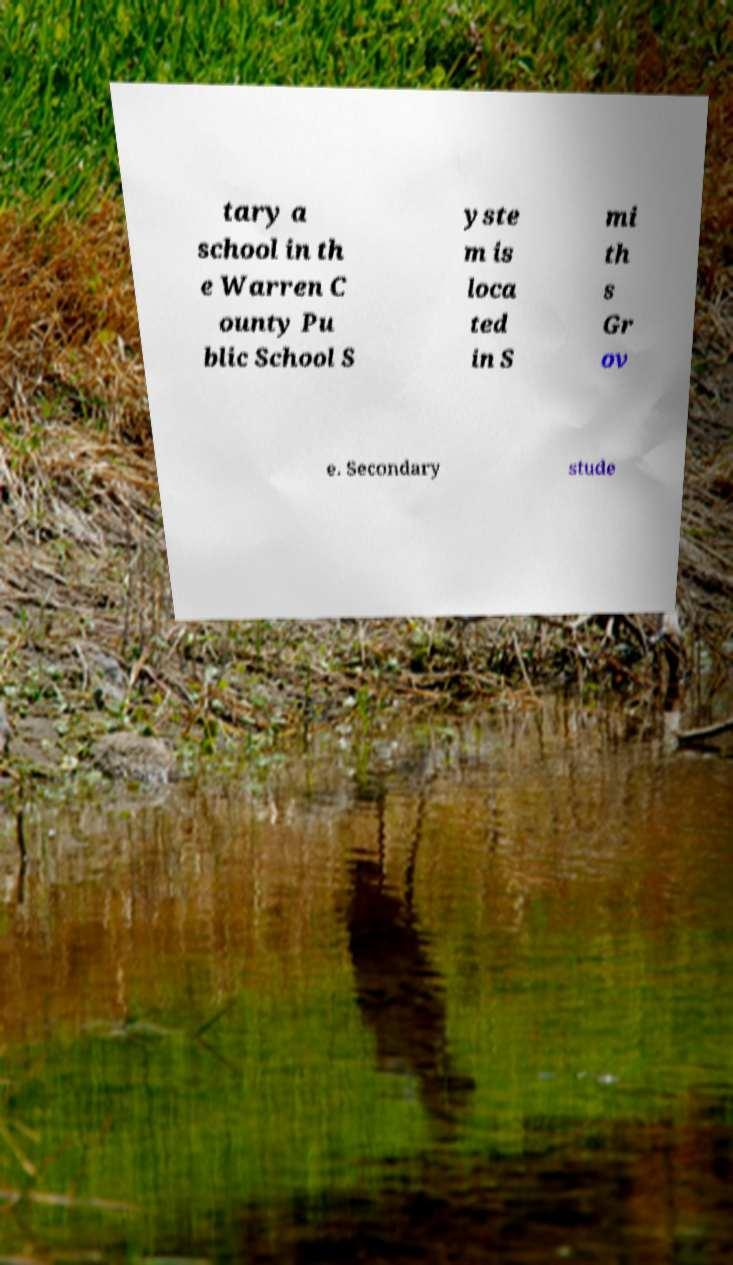Please read and relay the text visible in this image. What does it say? tary a school in th e Warren C ounty Pu blic School S yste m is loca ted in S mi th s Gr ov e. Secondary stude 